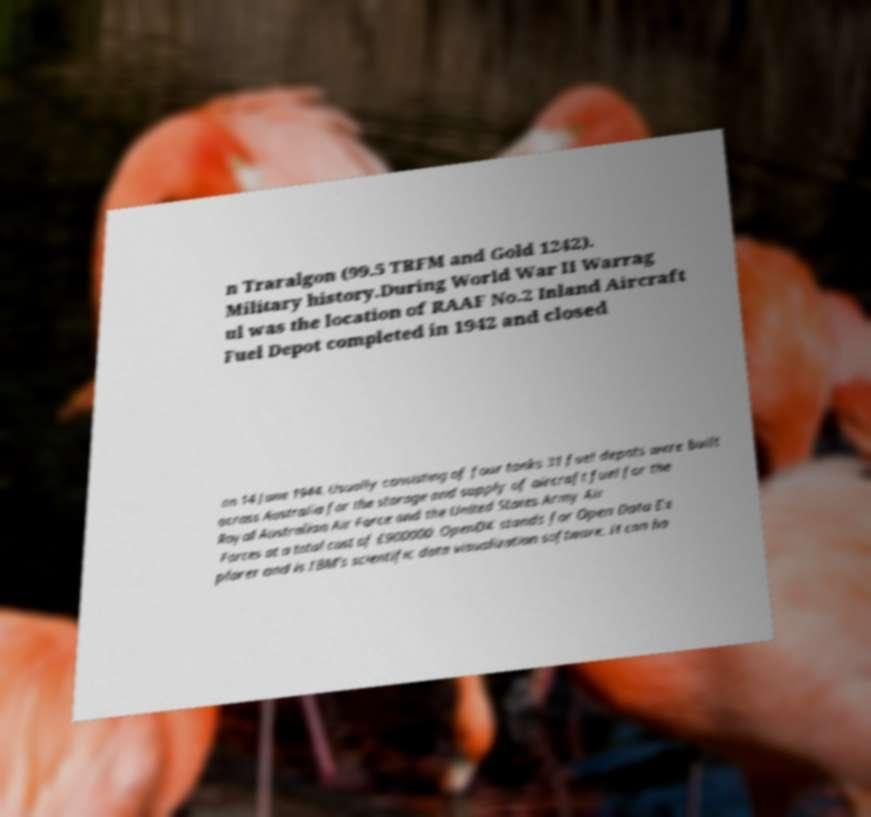What messages or text are displayed in this image? I need them in a readable, typed format. n Traralgon (99.5 TRFM and Gold 1242). Military history.During World War II Warrag ul was the location of RAAF No.2 Inland Aircraft Fuel Depot completed in 1942 and closed on 14 June 1944. Usually consisting of four tanks 31 fuel depots were built across Australia for the storage and supply of aircraft fuel for the Royal Australian Air Force and the United States Army Air Forces at a total cost of £900000 .OpenDX stands for Open Data Ex plorer and is IBM's scientific data visualization software. It can ha 